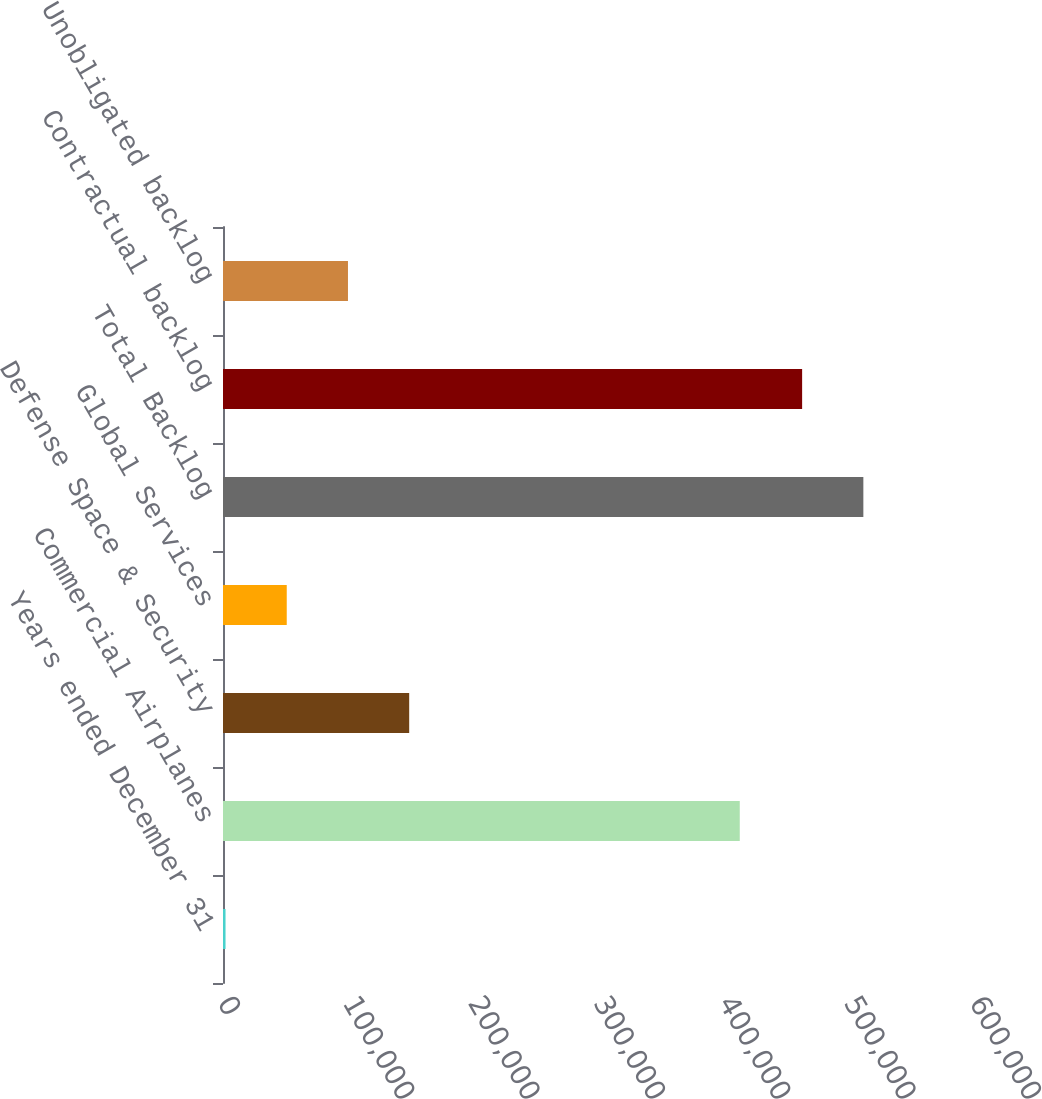Convert chart to OTSL. <chart><loc_0><loc_0><loc_500><loc_500><bar_chart><fcel>Years ended December 31<fcel>Commercial Airplanes<fcel>Defense Space & Security<fcel>Global Services<fcel>Total Backlog<fcel>Contractual backlog<fcel>Unobligated backlog<nl><fcel>2018<fcel>412307<fcel>148557<fcel>50864.3<fcel>510916<fcel>462070<fcel>99710.6<nl></chart> 